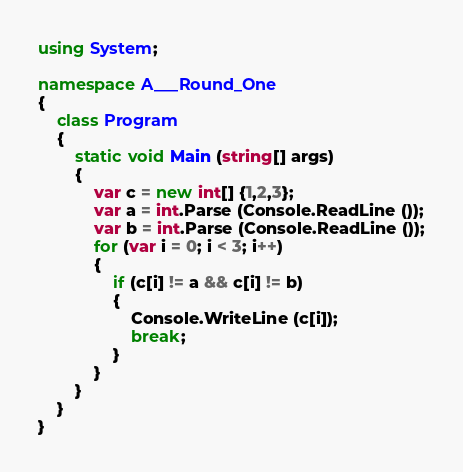<code> <loc_0><loc_0><loc_500><loc_500><_C#_>using System;

namespace A___Round_One
{
    class Program
    {
        static void Main (string[] args)
        {
            var c = new int[] {1,2,3};
            var a = int.Parse (Console.ReadLine ());
            var b = int.Parse (Console.ReadLine ());
            for (var i = 0; i < 3; i++)
            {
                if (c[i] != a && c[i] != b)
                {
                    Console.WriteLine (c[i]);
                    break;
                }
            }
        }
    }
}</code> 